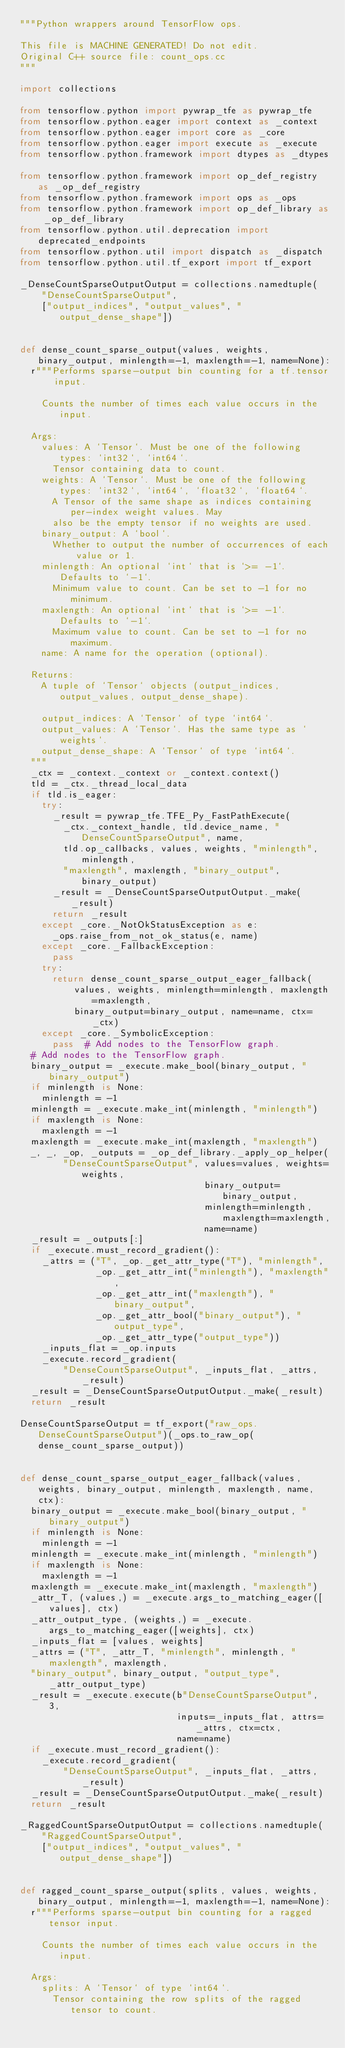<code> <loc_0><loc_0><loc_500><loc_500><_Python_>"""Python wrappers around TensorFlow ops.

This file is MACHINE GENERATED! Do not edit.
Original C++ source file: count_ops.cc
"""

import collections

from tensorflow.python import pywrap_tfe as pywrap_tfe
from tensorflow.python.eager import context as _context
from tensorflow.python.eager import core as _core
from tensorflow.python.eager import execute as _execute
from tensorflow.python.framework import dtypes as _dtypes

from tensorflow.python.framework import op_def_registry as _op_def_registry
from tensorflow.python.framework import ops as _ops
from tensorflow.python.framework import op_def_library as _op_def_library
from tensorflow.python.util.deprecation import deprecated_endpoints
from tensorflow.python.util import dispatch as _dispatch
from tensorflow.python.util.tf_export import tf_export

_DenseCountSparseOutputOutput = collections.namedtuple(
    "DenseCountSparseOutput",
    ["output_indices", "output_values", "output_dense_shape"])


def dense_count_sparse_output(values, weights, binary_output, minlength=-1, maxlength=-1, name=None):
  r"""Performs sparse-output bin counting for a tf.tensor input.

    Counts the number of times each value occurs in the input.

  Args:
    values: A `Tensor`. Must be one of the following types: `int32`, `int64`.
      Tensor containing data to count.
    weights: A `Tensor`. Must be one of the following types: `int32`, `int64`, `float32`, `float64`.
      A Tensor of the same shape as indices containing per-index weight values. May
      also be the empty tensor if no weights are used.
    binary_output: A `bool`.
      Whether to output the number of occurrences of each value or 1.
    minlength: An optional `int` that is `>= -1`. Defaults to `-1`.
      Minimum value to count. Can be set to -1 for no minimum.
    maxlength: An optional `int` that is `>= -1`. Defaults to `-1`.
      Maximum value to count. Can be set to -1 for no maximum.
    name: A name for the operation (optional).

  Returns:
    A tuple of `Tensor` objects (output_indices, output_values, output_dense_shape).

    output_indices: A `Tensor` of type `int64`.
    output_values: A `Tensor`. Has the same type as `weights`.
    output_dense_shape: A `Tensor` of type `int64`.
  """
  _ctx = _context._context or _context.context()
  tld = _ctx._thread_local_data
  if tld.is_eager:
    try:
      _result = pywrap_tfe.TFE_Py_FastPathExecute(
        _ctx._context_handle, tld.device_name, "DenseCountSparseOutput", name,
        tld.op_callbacks, values, weights, "minlength", minlength,
        "maxlength", maxlength, "binary_output", binary_output)
      _result = _DenseCountSparseOutputOutput._make(_result)
      return _result
    except _core._NotOkStatusException as e:
      _ops.raise_from_not_ok_status(e, name)
    except _core._FallbackException:
      pass
    try:
      return dense_count_sparse_output_eager_fallback(
          values, weights, minlength=minlength, maxlength=maxlength,
          binary_output=binary_output, name=name, ctx=_ctx)
    except _core._SymbolicException:
      pass  # Add nodes to the TensorFlow graph.
  # Add nodes to the TensorFlow graph.
  binary_output = _execute.make_bool(binary_output, "binary_output")
  if minlength is None:
    minlength = -1
  minlength = _execute.make_int(minlength, "minlength")
  if maxlength is None:
    maxlength = -1
  maxlength = _execute.make_int(maxlength, "maxlength")
  _, _, _op, _outputs = _op_def_library._apply_op_helper(
        "DenseCountSparseOutput", values=values, weights=weights,
                                  binary_output=binary_output,
                                  minlength=minlength, maxlength=maxlength,
                                  name=name)
  _result = _outputs[:]
  if _execute.must_record_gradient():
    _attrs = ("T", _op._get_attr_type("T"), "minlength",
              _op._get_attr_int("minlength"), "maxlength",
              _op._get_attr_int("maxlength"), "binary_output",
              _op._get_attr_bool("binary_output"), "output_type",
              _op._get_attr_type("output_type"))
    _inputs_flat = _op.inputs
    _execute.record_gradient(
        "DenseCountSparseOutput", _inputs_flat, _attrs, _result)
  _result = _DenseCountSparseOutputOutput._make(_result)
  return _result

DenseCountSparseOutput = tf_export("raw_ops.DenseCountSparseOutput")(_ops.to_raw_op(dense_count_sparse_output))


def dense_count_sparse_output_eager_fallback(values, weights, binary_output, minlength, maxlength, name, ctx):
  binary_output = _execute.make_bool(binary_output, "binary_output")
  if minlength is None:
    minlength = -1
  minlength = _execute.make_int(minlength, "minlength")
  if maxlength is None:
    maxlength = -1
  maxlength = _execute.make_int(maxlength, "maxlength")
  _attr_T, (values,) = _execute.args_to_matching_eager([values], ctx)
  _attr_output_type, (weights,) = _execute.args_to_matching_eager([weights], ctx)
  _inputs_flat = [values, weights]
  _attrs = ("T", _attr_T, "minlength", minlength, "maxlength", maxlength,
  "binary_output", binary_output, "output_type", _attr_output_type)
  _result = _execute.execute(b"DenseCountSparseOutput", 3,
                             inputs=_inputs_flat, attrs=_attrs, ctx=ctx,
                             name=name)
  if _execute.must_record_gradient():
    _execute.record_gradient(
        "DenseCountSparseOutput", _inputs_flat, _attrs, _result)
  _result = _DenseCountSparseOutputOutput._make(_result)
  return _result

_RaggedCountSparseOutputOutput = collections.namedtuple(
    "RaggedCountSparseOutput",
    ["output_indices", "output_values", "output_dense_shape"])


def ragged_count_sparse_output(splits, values, weights, binary_output, minlength=-1, maxlength=-1, name=None):
  r"""Performs sparse-output bin counting for a ragged tensor input.

    Counts the number of times each value occurs in the input.

  Args:
    splits: A `Tensor` of type `int64`.
      Tensor containing the row splits of the ragged tensor to count.</code> 